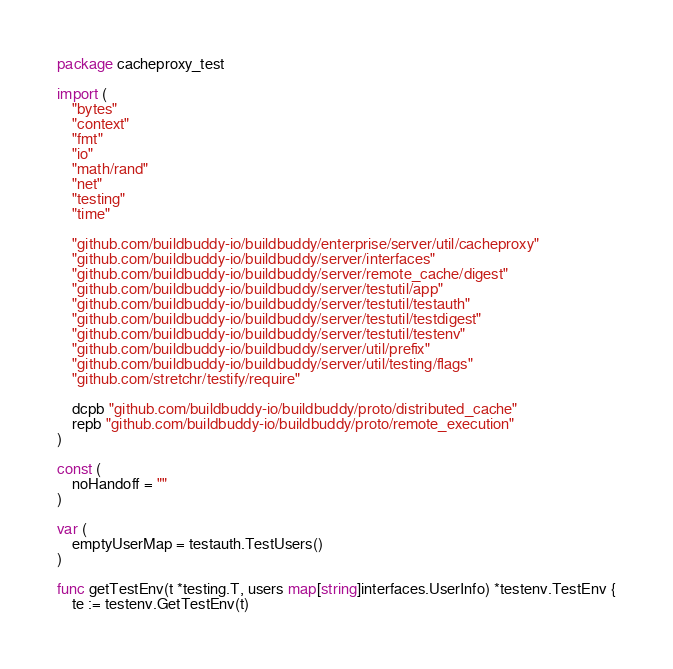<code> <loc_0><loc_0><loc_500><loc_500><_Go_>package cacheproxy_test

import (
	"bytes"
	"context"
	"fmt"
	"io"
	"math/rand"
	"net"
	"testing"
	"time"

	"github.com/buildbuddy-io/buildbuddy/enterprise/server/util/cacheproxy"
	"github.com/buildbuddy-io/buildbuddy/server/interfaces"
	"github.com/buildbuddy-io/buildbuddy/server/remote_cache/digest"
	"github.com/buildbuddy-io/buildbuddy/server/testutil/app"
	"github.com/buildbuddy-io/buildbuddy/server/testutil/testauth"
	"github.com/buildbuddy-io/buildbuddy/server/testutil/testdigest"
	"github.com/buildbuddy-io/buildbuddy/server/testutil/testenv"
	"github.com/buildbuddy-io/buildbuddy/server/util/prefix"
	"github.com/buildbuddy-io/buildbuddy/server/util/testing/flags"
	"github.com/stretchr/testify/require"

	dcpb "github.com/buildbuddy-io/buildbuddy/proto/distributed_cache"
	repb "github.com/buildbuddy-io/buildbuddy/proto/remote_execution"
)

const (
	noHandoff = ""
)

var (
	emptyUserMap = testauth.TestUsers()
)

func getTestEnv(t *testing.T, users map[string]interfaces.UserInfo) *testenv.TestEnv {
	te := testenv.GetTestEnv(t)</code> 